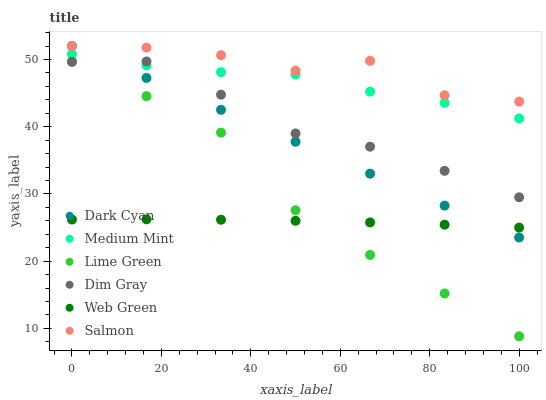Does Web Green have the minimum area under the curve?
Answer yes or no. Yes. Does Salmon have the maximum area under the curve?
Answer yes or no. Yes. Does Dim Gray have the minimum area under the curve?
Answer yes or no. No. Does Dim Gray have the maximum area under the curve?
Answer yes or no. No. Is Dark Cyan the smoothest?
Answer yes or no. Yes. Is Salmon the roughest?
Answer yes or no. Yes. Is Dim Gray the smoothest?
Answer yes or no. No. Is Dim Gray the roughest?
Answer yes or no. No. Does Lime Green have the lowest value?
Answer yes or no. Yes. Does Dim Gray have the lowest value?
Answer yes or no. No. Does Dark Cyan have the highest value?
Answer yes or no. Yes. Does Dim Gray have the highest value?
Answer yes or no. No. Is Web Green less than Dim Gray?
Answer yes or no. Yes. Is Medium Mint greater than Lime Green?
Answer yes or no. Yes. Does Salmon intersect Dark Cyan?
Answer yes or no. Yes. Is Salmon less than Dark Cyan?
Answer yes or no. No. Is Salmon greater than Dark Cyan?
Answer yes or no. No. Does Web Green intersect Dim Gray?
Answer yes or no. No. 